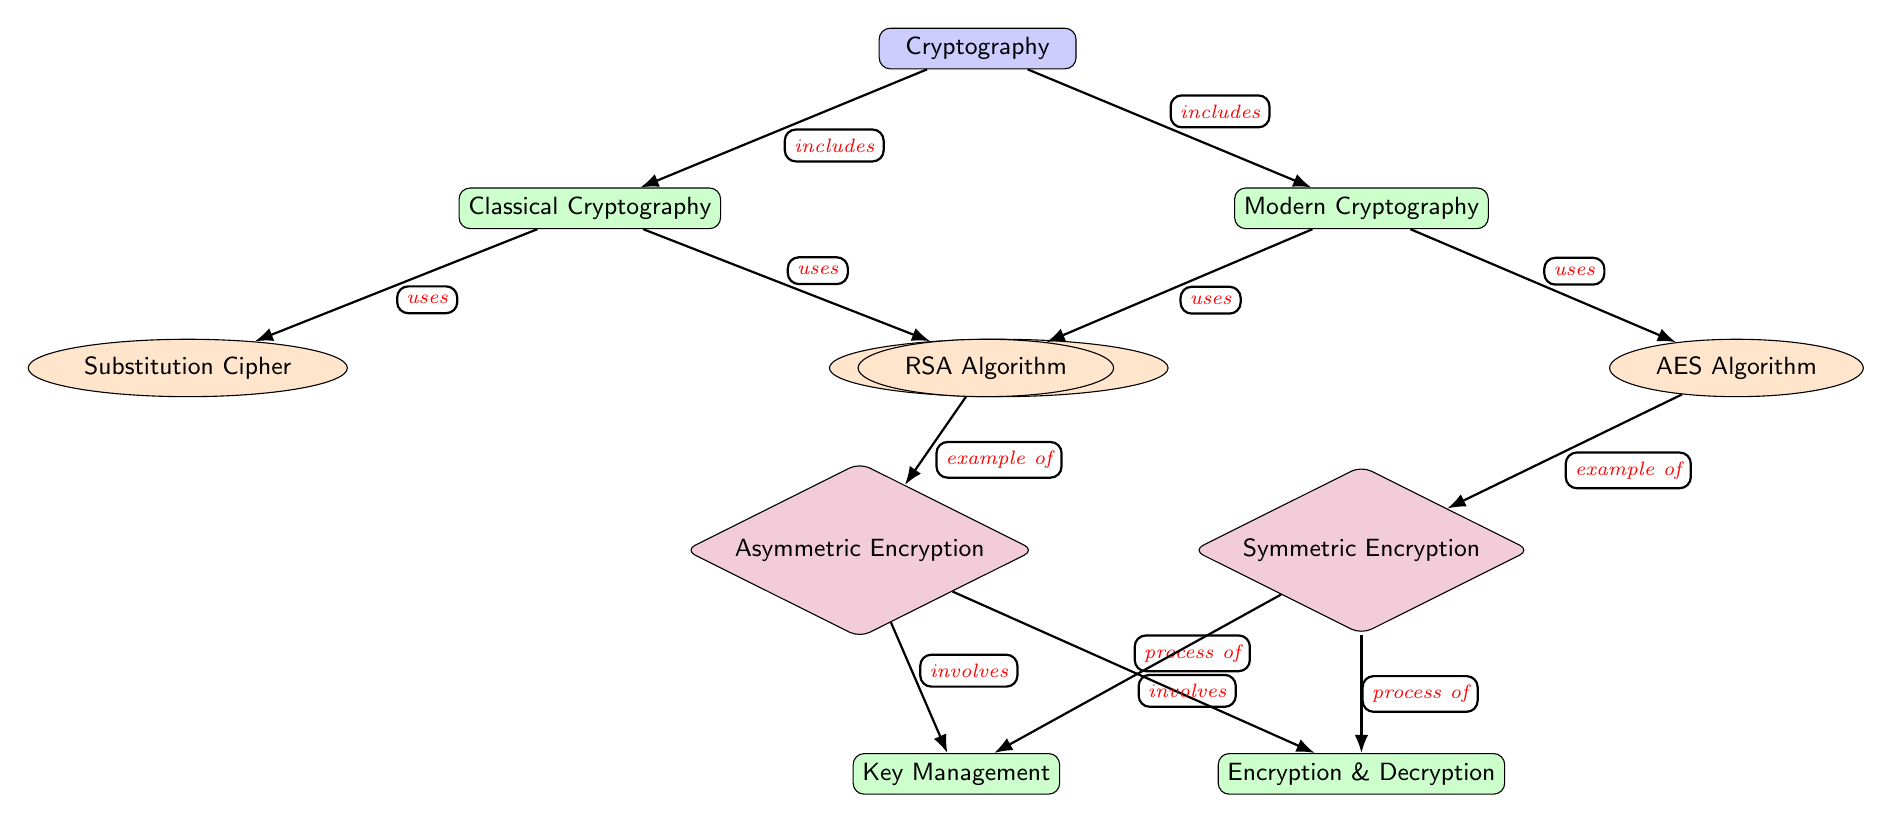What are the two main categories of cryptography depicted in the diagram? The diagram shows two main categories branching from the central node "Cryptography": "Classical Cryptography" and "Modern Cryptography". These two are the primary divisions of the field as per the visual representation.
Answer: Classical Cryptography, Modern Cryptography How many encryption algorithms are listed in the diagram? The diagram displays four specific encryption algorithms under the nodes "Classical Cryptography" and "Modern Cryptography": "Substitution Cipher", "Transposition Cipher", "RSA Algorithm", and "AES Algorithm". Counting these, we find there are four algorithms in total.
Answer: Four Which encryption method does the RSA Algorithm fall under? The RSA Algorithm, shown as a node under "Modern Cryptography", falls under the concept of "Asymmetric Encryption", which is also included in the diagram. This relationship is indicated by the edge connecting these two nodes.
Answer: Asymmetric Encryption What type of encryption is shown as an example under the AES Algorithm? The AES Algorithm, categorized as a node under "Modern Cryptography," is connected through an edge to "Symmetric Encryption", indicating that it is an example of this type of encryption.
Answer: Symmetric Encryption Which component of the diagram involves "Key Management"? "Key Management" is illustrated as a subnode that connects with both "Symmetric Encryption" and "Asymmetric Encryption" nodes. The edges indicate that key management is a process involved in both types of encryption.
Answer: Key Management How does "Encryption & Decryption" relate to "Symmetric Encryption"? In the diagram, "Encryption & Decryption" is positioned beneath "Symmetric Encryption" and is connected by an edge labeled "process of". This shows that "Encryption & Decryption" is a process that occurs within the context of "Symmetric Encryption".
Answer: process of What is the relationship between "Classical Cryptography" and "Substitution Cipher"? In the diagram, the relationship is indicated by an edge labeled "uses" flowing from "Classical Cryptography" to "Substitution Cipher". This signifies that substitution ciphers are a tool utilized within classical cryptographic methods.
Answer: uses Which two types of encryption processes are mentioned in the diagram? The diagram identifies two distinct types of encryption processes: "Symmetric Encryption" and "Asymmetric Encryption". These are labeled nodes that show the categorization of encryption methods based on key usage.
Answer: Symmetric Encryption, Asymmetric Encryption What does the edge between "RSA Algorithm" and "Asymmetric Encryption" signify? The edge connects "RSA Algorithm" to "Asymmetric Encryption", labeled as "example of". This signifies that the RSA Algorithm serves as a specific instance or example of asymmetric encryption methods.
Answer: example of 